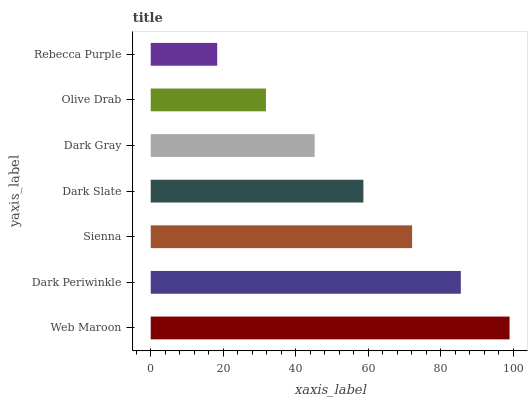Is Rebecca Purple the minimum?
Answer yes or no. Yes. Is Web Maroon the maximum?
Answer yes or no. Yes. Is Dark Periwinkle the minimum?
Answer yes or no. No. Is Dark Periwinkle the maximum?
Answer yes or no. No. Is Web Maroon greater than Dark Periwinkle?
Answer yes or no. Yes. Is Dark Periwinkle less than Web Maroon?
Answer yes or no. Yes. Is Dark Periwinkle greater than Web Maroon?
Answer yes or no. No. Is Web Maroon less than Dark Periwinkle?
Answer yes or no. No. Is Dark Slate the high median?
Answer yes or no. Yes. Is Dark Slate the low median?
Answer yes or no. Yes. Is Sienna the high median?
Answer yes or no. No. Is Sienna the low median?
Answer yes or no. No. 